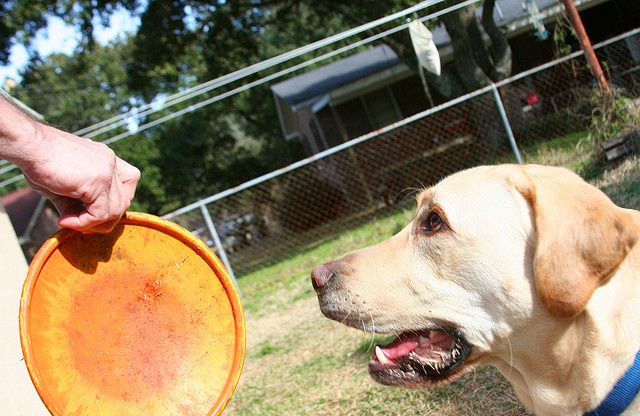Describe the objects in this image and their specific colors. I can see dog in black, ivory, tan, and gray tones, frisbee in black, orange, gold, and khaki tones, people in black, pink, lightpink, maroon, and brown tones, and car in black, gray, and darkgray tones in this image. 